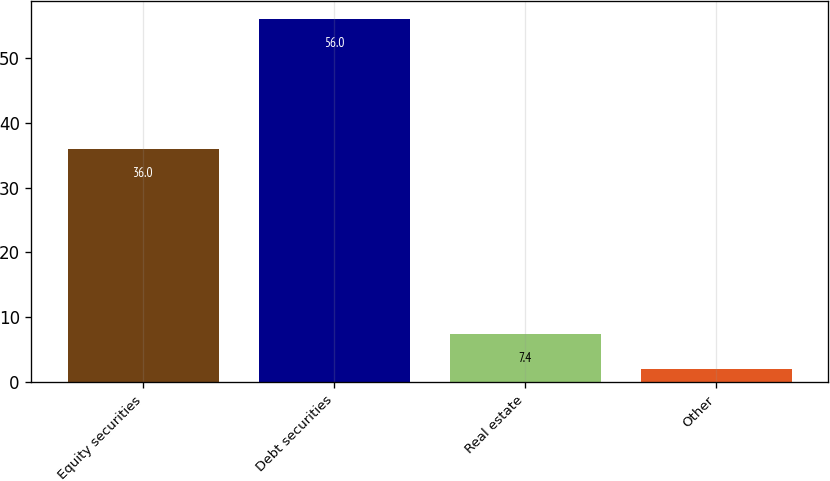Convert chart to OTSL. <chart><loc_0><loc_0><loc_500><loc_500><bar_chart><fcel>Equity securities<fcel>Debt securities<fcel>Real estate<fcel>Other<nl><fcel>36<fcel>56<fcel>7.4<fcel>2<nl></chart> 